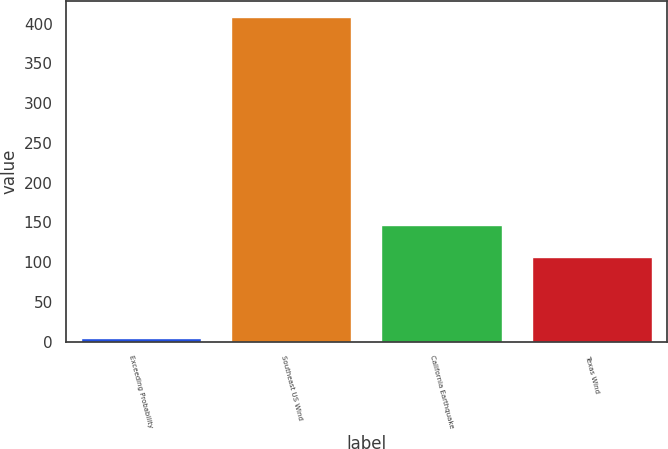<chart> <loc_0><loc_0><loc_500><loc_500><bar_chart><fcel>Exceeding Probability<fcel>Southeast US Wind<fcel>California Earthquake<fcel>Texas Wind<nl><fcel>5<fcel>408<fcel>147.3<fcel>107<nl></chart> 